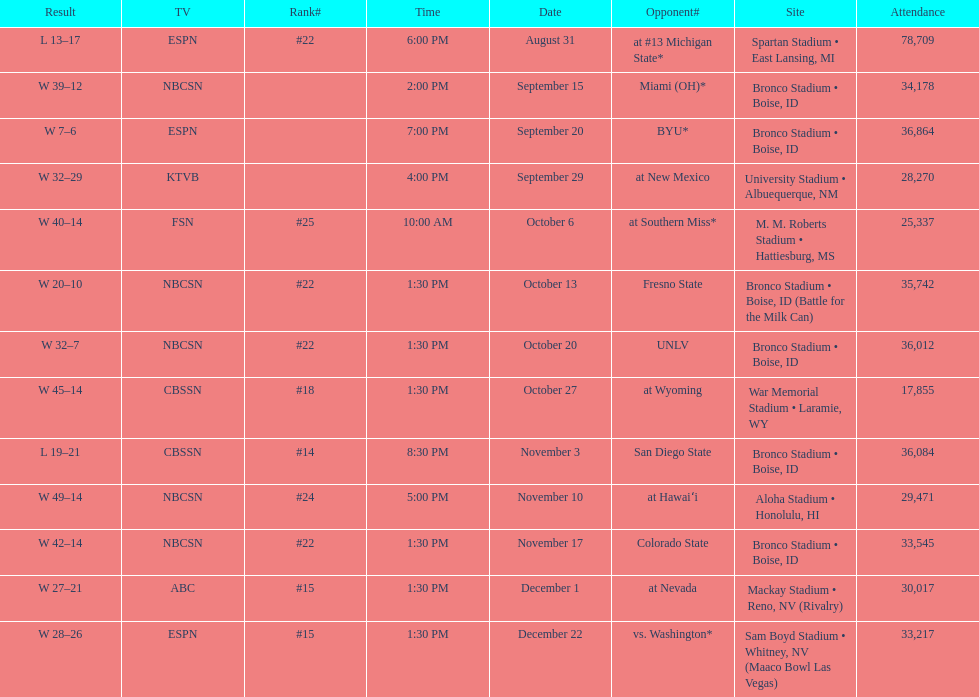Opponent broncos faced next after unlv Wyoming. 